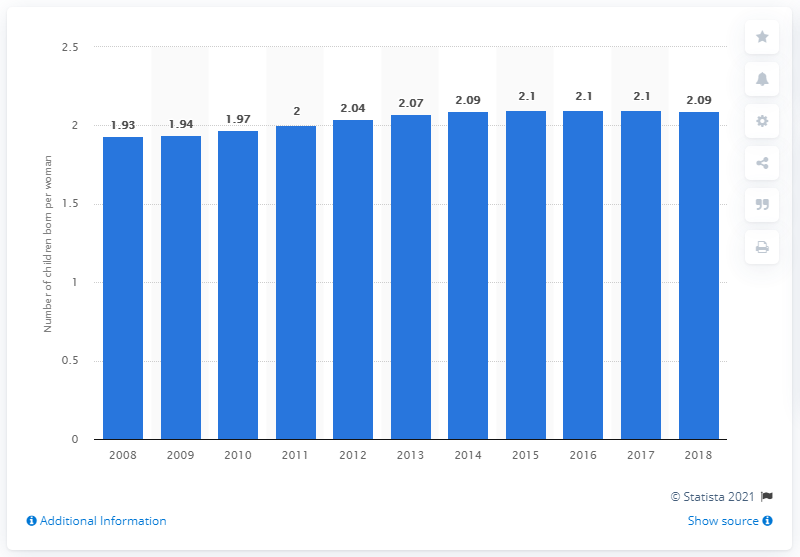Outline some significant characteristics in this image. In 2018, the fertility rate in Lebanon was 2.09. 